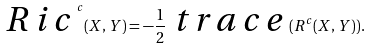Convert formula to latex. <formula><loc_0><loc_0><loc_500><loc_500>\emph { R i c } ^ { c } ( X , Y ) = - \frac { 1 } { 2 } \emph { t r a c e } ( R ^ { c } ( X , Y ) ) .</formula> 